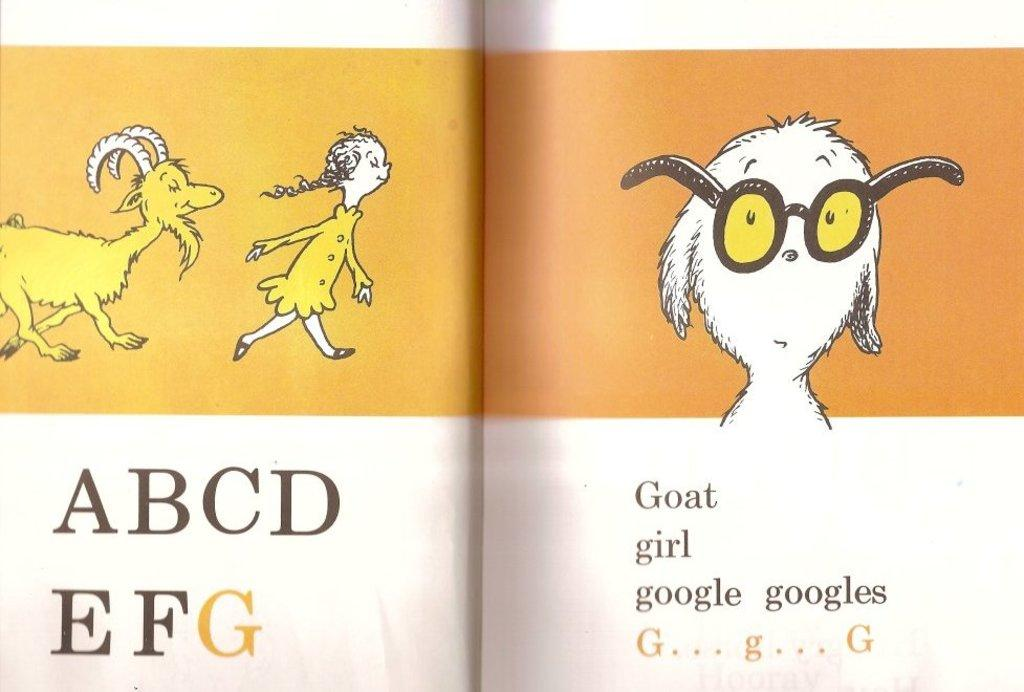What is the main object in the image? There is an open book in the image. What type of content can be found in the book? The book contains text and pictures. What type of industry is depicted in the image? There is no industry depicted in the image; it features an open book with text and pictures. What kind of bait is used in the image? There is no bait present in the image; it features an open book with text and pictures. 